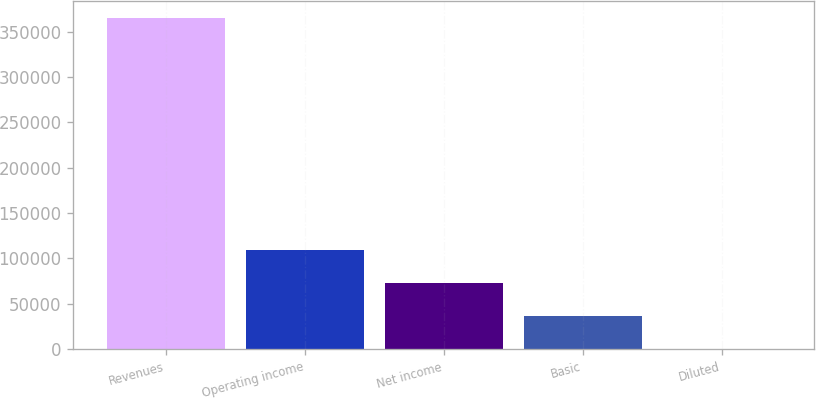Convert chart to OTSL. <chart><loc_0><loc_0><loc_500><loc_500><bar_chart><fcel>Revenues<fcel>Operating income<fcel>Net income<fcel>Basic<fcel>Diluted<nl><fcel>365543<fcel>109663<fcel>73108.9<fcel>36554.6<fcel>0.32<nl></chart> 